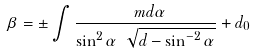<formula> <loc_0><loc_0><loc_500><loc_500>\beta = \pm \int \frac { \ m d \alpha } { \sin ^ { 2 } \alpha \ \sqrt { d - \sin ^ { - 2 } \alpha } } + d _ { 0 }</formula> 